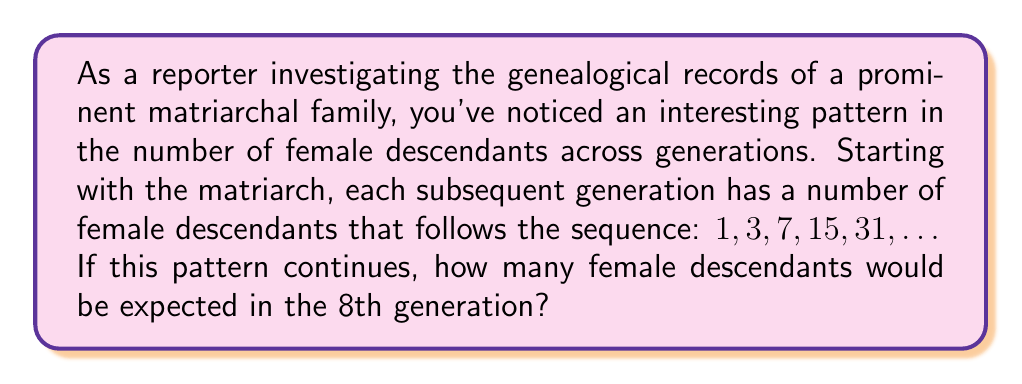Give your solution to this math problem. To solve this problem, we need to analyze the given sequence and identify the pattern. Let's break it down step-by-step:

1. First, let's examine the given sequence: $1, 3, 7, 15, 31, \ldots$

2. To find the pattern, let's calculate the differences between consecutive terms:
   $3 - 1 = 2$
   $7 - 3 = 4$
   $15 - 7 = 8$
   $31 - 15 = 16$

3. We can observe that the differences are doubling each time: $2, 4, 8, 16, \ldots$
   This suggests that each term is being multiplied by 2 and then 1 is added.

4. We can express this pattern mathematically as:
   $a_n = 2a_{n-1} + 1$, where $a_n$ is the nth term of the sequence.

5. Alternatively, we can express the general term of this sequence as:
   $a_n = 2^n - 1$, where n is the generation number (starting from 0 for the matriarch).

6. To find the number of female descendants in the 8th generation, we need to calculate $a_7$ (since we start counting at 0):

   $a_7 = 2^7 - 1$

7. Let's calculate this:
   $2^7 = 128$
   $128 - 1 = 127$

Therefore, in the 8th generation (index 7 in our sequence), we would expect 127 female descendants.
Answer: 127 female descendants 